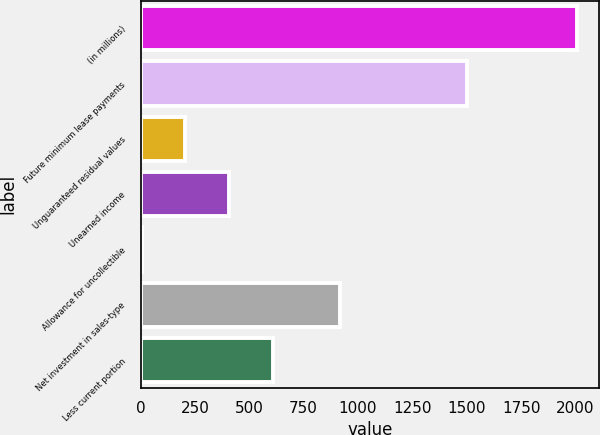<chart> <loc_0><loc_0><loc_500><loc_500><bar_chart><fcel>(in millions)<fcel>Future minimum lease payments<fcel>Unguaranteed residual values<fcel>Unearned income<fcel>Allowance for uncollectible<fcel>Net investment in sales-type<fcel>Less current portion<nl><fcel>2008<fcel>1500.64<fcel>206.74<fcel>406.88<fcel>6.6<fcel>916.8<fcel>607.02<nl></chart> 